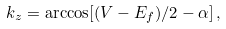<formula> <loc_0><loc_0><loc_500><loc_500>k _ { z } = \arccos [ ( V - E _ { f } ) / 2 - \alpha ] \, ,</formula> 